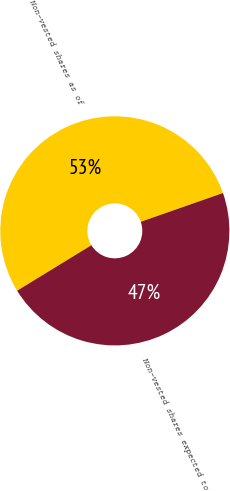Convert chart. <chart><loc_0><loc_0><loc_500><loc_500><pie_chart><fcel>Non-vested shares as of<fcel>Non-vested shares expected to<nl><fcel>53.39%<fcel>46.61%<nl></chart> 